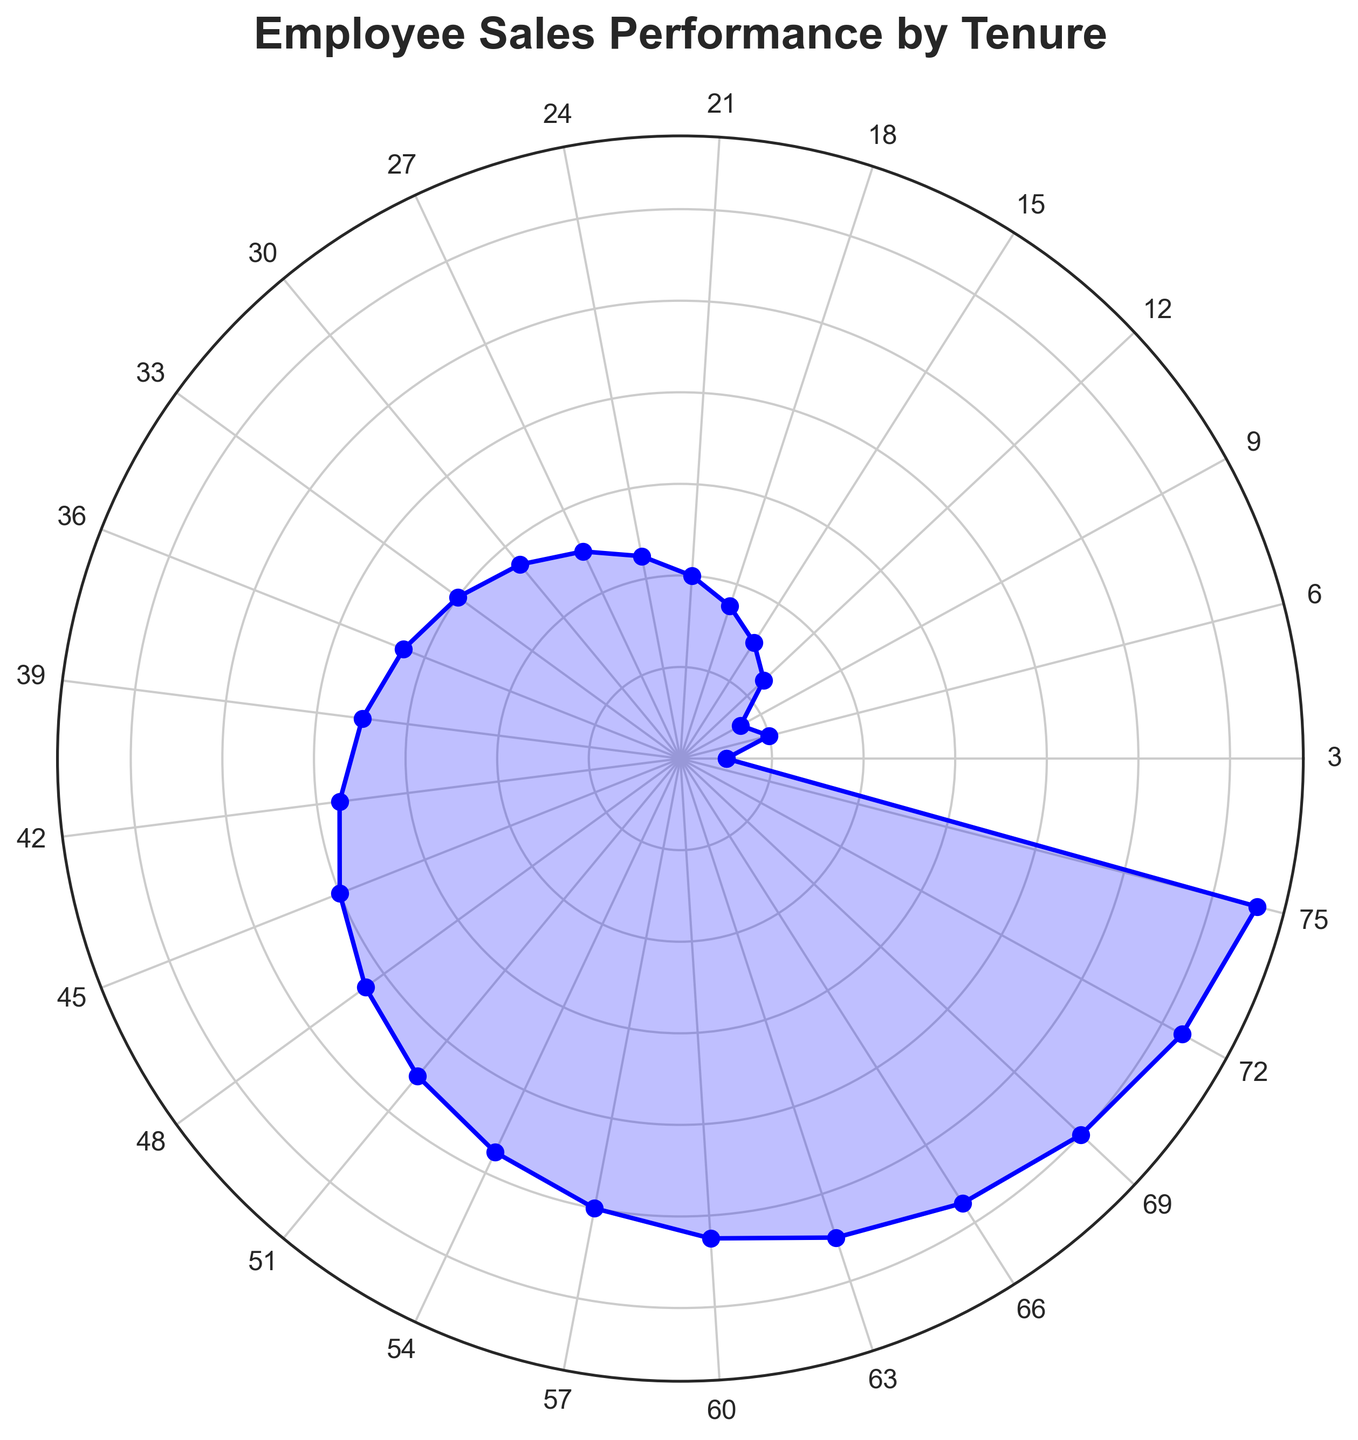Which employee has the highest sales performance? By looking at the figure, identify the point at the highest radial distance from the center, which represents the employee with the highest sales performance. The highest point is at the tenure marked as 75 months.
Answer: E025 Comparing employees with 36 months and 54 months of tenure, who has a higher sales performance? Find the points corresponding to 36 months and 54 months of tenure and compare their radial distances from the center. The point at 54 months is farther out.
Answer: Employee at 54 months What's the average sales performance for employees with 24, 48, and 72 months of tenure? Find the points corresponding to these tenures on the figure and note their values: 45, 85, and 125. Compute the average of (45 + 85 + 125) / 3.
Answer: 85 How does the sales performance trend change with increasing tenure? Observe the radial distances of points as you move around the circle, noting how sales performance increases almost linearly with tenure.
Answer: Increasing trend Are there any dips or irregularities in the sales performance trend? Scan the points for any inconsistencies or drops in the overall increasing trend. All points follow a smooth, increasing pattern.
Answer: No What is the difference in sales performance between employees with 15 and 45 months of tenure? Identify the points for 15 months and 45 months of tenure and subtract their sales performance values: 80 - 30.
Answer: 50 What range of sales performance values is represented in the chart? Determine the minimum and maximum sales performance points in the radial plot. The minimum is 10 (3 months), and the maximum is 130 (75 months).
Answer: 10 to 130 Which tenure corresponds to a marked performance increase from the previous tenure? Look for a point where a significant jump in radial distance occurs compared to the previous point. There is a consistent increase without marked jumps.
Answer: Consistent increase Between 18 months and 42 months tenure, which one has a closer sales performance to the average sales performance (67.5) in this data set? Calculate the sales performance for 18 months (35) and 42 months (75), and then check which is closer to 67.5.
Answer: 42 months If two employees have sales performances of 35 and 95, what are their tenures? Locate the sales performance values on the figure and read the corresponding tenure values. 35 corresponds to 18 months, and 95 corresponds to 54 months.
Answer: 18 and 54 months 